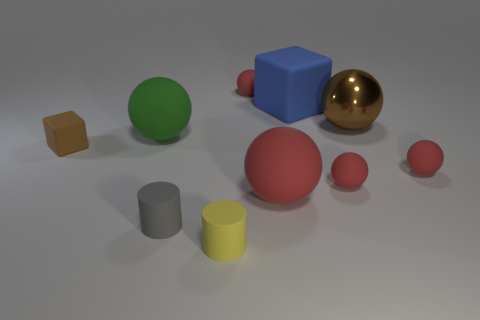What could be the purpose of this arrangement of objects? The setup looks like it might be for a study of geometry, color perception, or a visual representation of objects for an educational purpose. It might also be a simple artistic composition to compare and contrast different shapes and colors, or even a part of a rendering test for 3D modeling software to showcase textures and reflections. 